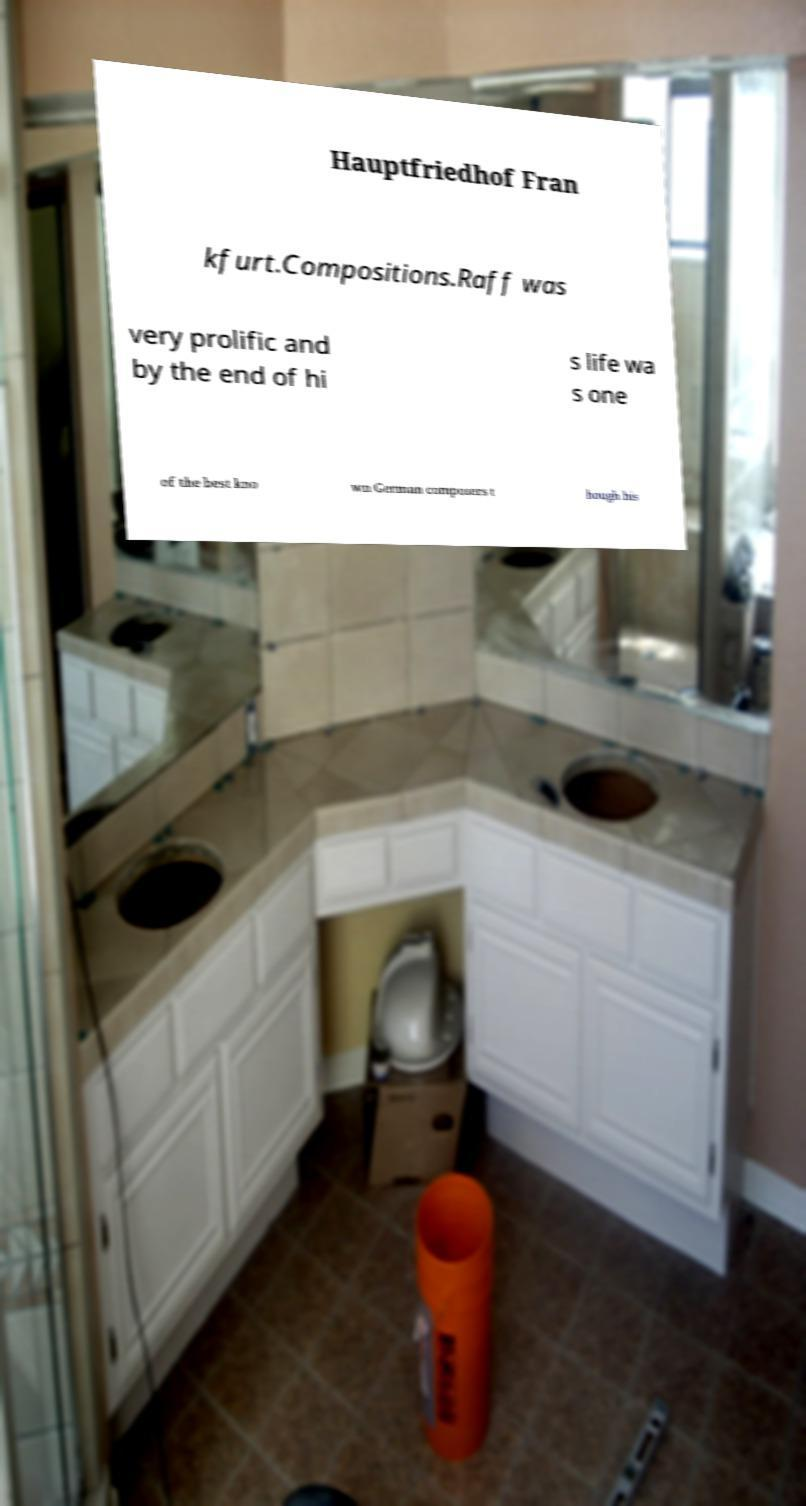Could you extract and type out the text from this image? Hauptfriedhof Fran kfurt.Compositions.Raff was very prolific and by the end of hi s life wa s one of the best kno wn German composers t hough his 